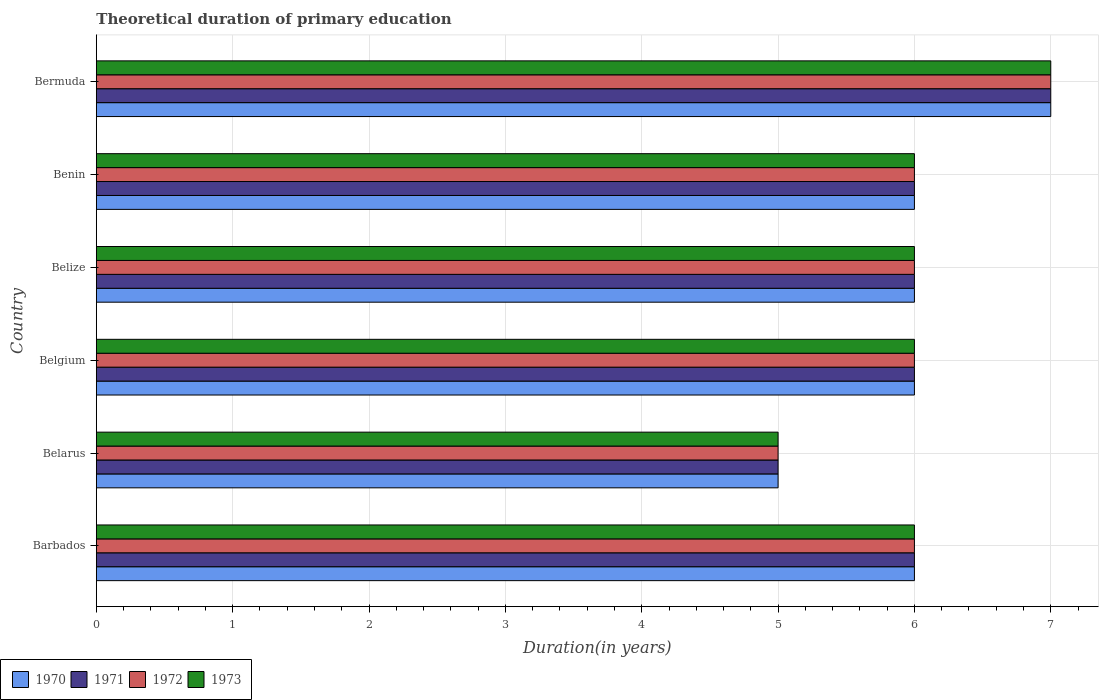How many different coloured bars are there?
Your answer should be compact. 4. How many groups of bars are there?
Your answer should be compact. 6. Are the number of bars on each tick of the Y-axis equal?
Your response must be concise. Yes. What is the label of the 1st group of bars from the top?
Provide a succinct answer. Bermuda. In how many cases, is the number of bars for a given country not equal to the number of legend labels?
Your response must be concise. 0. Across all countries, what is the minimum total theoretical duration of primary education in 1972?
Give a very brief answer. 5. In which country was the total theoretical duration of primary education in 1972 maximum?
Ensure brevity in your answer.  Bermuda. In which country was the total theoretical duration of primary education in 1973 minimum?
Your answer should be very brief. Belarus. What is the total total theoretical duration of primary education in 1970 in the graph?
Make the answer very short. 36. What is the difference between the total theoretical duration of primary education in 1970 in Belize and that in Bermuda?
Offer a terse response. -1. What is the average total theoretical duration of primary education in 1971 per country?
Give a very brief answer. 6. In how many countries, is the total theoretical duration of primary education in 1971 greater than 0.8 years?
Provide a succinct answer. 6. What is the ratio of the total theoretical duration of primary education in 1972 in Belgium to that in Bermuda?
Keep it short and to the point. 0.86. What is the difference between the highest and the second highest total theoretical duration of primary education in 1973?
Ensure brevity in your answer.  1. What is the difference between the highest and the lowest total theoretical duration of primary education in 1972?
Provide a succinct answer. 2. In how many countries, is the total theoretical duration of primary education in 1971 greater than the average total theoretical duration of primary education in 1971 taken over all countries?
Your response must be concise. 1. What does the 1st bar from the bottom in Belarus represents?
Your response must be concise. 1970. How many countries are there in the graph?
Your answer should be very brief. 6. How many legend labels are there?
Your response must be concise. 4. What is the title of the graph?
Make the answer very short. Theoretical duration of primary education. What is the label or title of the X-axis?
Ensure brevity in your answer.  Duration(in years). What is the label or title of the Y-axis?
Make the answer very short. Country. What is the Duration(in years) of 1971 in Barbados?
Ensure brevity in your answer.  6. What is the Duration(in years) of 1973 in Barbados?
Provide a succinct answer. 6. What is the Duration(in years) of 1970 in Belarus?
Your answer should be compact. 5. What is the Duration(in years) in 1972 in Belarus?
Your answer should be very brief. 5. What is the Duration(in years) of 1973 in Belarus?
Give a very brief answer. 5. What is the Duration(in years) in 1971 in Belgium?
Ensure brevity in your answer.  6. What is the Duration(in years) of 1973 in Belgium?
Your response must be concise. 6. What is the Duration(in years) in 1970 in Belize?
Your answer should be very brief. 6. What is the Duration(in years) in 1971 in Belize?
Provide a short and direct response. 6. What is the Duration(in years) of 1973 in Belize?
Keep it short and to the point. 6. What is the Duration(in years) of 1971 in Benin?
Make the answer very short. 6. What is the Duration(in years) of 1972 in Benin?
Provide a short and direct response. 6. What is the Duration(in years) of 1970 in Bermuda?
Offer a terse response. 7. Across all countries, what is the maximum Duration(in years) of 1972?
Offer a very short reply. 7. Across all countries, what is the maximum Duration(in years) in 1973?
Keep it short and to the point. 7. Across all countries, what is the minimum Duration(in years) of 1971?
Your answer should be very brief. 5. Across all countries, what is the minimum Duration(in years) of 1973?
Provide a short and direct response. 5. What is the total Duration(in years) in 1970 in the graph?
Your response must be concise. 36. What is the total Duration(in years) in 1971 in the graph?
Provide a succinct answer. 36. What is the total Duration(in years) of 1972 in the graph?
Provide a short and direct response. 36. What is the total Duration(in years) in 1973 in the graph?
Your answer should be compact. 36. What is the difference between the Duration(in years) in 1970 in Barbados and that in Belarus?
Make the answer very short. 1. What is the difference between the Duration(in years) of 1972 in Barbados and that in Belarus?
Offer a very short reply. 1. What is the difference between the Duration(in years) of 1970 in Barbados and that in Belgium?
Provide a short and direct response. 0. What is the difference between the Duration(in years) in 1972 in Barbados and that in Belgium?
Provide a succinct answer. 0. What is the difference between the Duration(in years) of 1970 in Barbados and that in Belize?
Your answer should be compact. 0. What is the difference between the Duration(in years) of 1971 in Barbados and that in Belize?
Your answer should be very brief. 0. What is the difference between the Duration(in years) of 1970 in Barbados and that in Benin?
Offer a terse response. 0. What is the difference between the Duration(in years) of 1972 in Barbados and that in Benin?
Your answer should be compact. 0. What is the difference between the Duration(in years) of 1970 in Barbados and that in Bermuda?
Provide a succinct answer. -1. What is the difference between the Duration(in years) in 1971 in Barbados and that in Bermuda?
Make the answer very short. -1. What is the difference between the Duration(in years) in 1972 in Barbados and that in Bermuda?
Keep it short and to the point. -1. What is the difference between the Duration(in years) of 1970 in Belarus and that in Belgium?
Keep it short and to the point. -1. What is the difference between the Duration(in years) of 1971 in Belarus and that in Belgium?
Your answer should be very brief. -1. What is the difference between the Duration(in years) in 1972 in Belarus and that in Belgium?
Give a very brief answer. -1. What is the difference between the Duration(in years) in 1973 in Belarus and that in Belgium?
Offer a terse response. -1. What is the difference between the Duration(in years) in 1970 in Belarus and that in Belize?
Your answer should be compact. -1. What is the difference between the Duration(in years) in 1971 in Belarus and that in Belize?
Give a very brief answer. -1. What is the difference between the Duration(in years) in 1973 in Belarus and that in Belize?
Your response must be concise. -1. What is the difference between the Duration(in years) in 1970 in Belarus and that in Benin?
Ensure brevity in your answer.  -1. What is the difference between the Duration(in years) of 1971 in Belarus and that in Benin?
Offer a terse response. -1. What is the difference between the Duration(in years) of 1973 in Belarus and that in Benin?
Offer a terse response. -1. What is the difference between the Duration(in years) in 1972 in Belarus and that in Bermuda?
Your answer should be very brief. -2. What is the difference between the Duration(in years) in 1970 in Belgium and that in Belize?
Keep it short and to the point. 0. What is the difference between the Duration(in years) of 1970 in Belgium and that in Benin?
Make the answer very short. 0. What is the difference between the Duration(in years) in 1971 in Belgium and that in Bermuda?
Offer a terse response. -1. What is the difference between the Duration(in years) of 1973 in Belgium and that in Bermuda?
Ensure brevity in your answer.  -1. What is the difference between the Duration(in years) in 1970 in Belize and that in Benin?
Your answer should be compact. 0. What is the difference between the Duration(in years) in 1972 in Belize and that in Benin?
Give a very brief answer. 0. What is the difference between the Duration(in years) in 1970 in Belize and that in Bermuda?
Your response must be concise. -1. What is the difference between the Duration(in years) in 1971 in Belize and that in Bermuda?
Make the answer very short. -1. What is the difference between the Duration(in years) in 1972 in Belize and that in Bermuda?
Offer a terse response. -1. What is the difference between the Duration(in years) in 1972 in Benin and that in Bermuda?
Offer a very short reply. -1. What is the difference between the Duration(in years) in 1970 in Barbados and the Duration(in years) in 1971 in Belarus?
Your response must be concise. 1. What is the difference between the Duration(in years) of 1970 in Barbados and the Duration(in years) of 1973 in Belarus?
Offer a very short reply. 1. What is the difference between the Duration(in years) of 1971 in Barbados and the Duration(in years) of 1972 in Belarus?
Your response must be concise. 1. What is the difference between the Duration(in years) in 1970 in Barbados and the Duration(in years) in 1972 in Belgium?
Give a very brief answer. 0. What is the difference between the Duration(in years) of 1970 in Barbados and the Duration(in years) of 1973 in Belgium?
Provide a short and direct response. 0. What is the difference between the Duration(in years) of 1971 in Barbados and the Duration(in years) of 1972 in Belgium?
Your answer should be very brief. 0. What is the difference between the Duration(in years) of 1972 in Barbados and the Duration(in years) of 1973 in Belgium?
Your answer should be very brief. 0. What is the difference between the Duration(in years) of 1970 in Barbados and the Duration(in years) of 1972 in Belize?
Give a very brief answer. 0. What is the difference between the Duration(in years) in 1970 in Barbados and the Duration(in years) in 1973 in Belize?
Make the answer very short. 0. What is the difference between the Duration(in years) of 1971 in Barbados and the Duration(in years) of 1972 in Benin?
Ensure brevity in your answer.  0. What is the difference between the Duration(in years) of 1971 in Barbados and the Duration(in years) of 1973 in Benin?
Ensure brevity in your answer.  0. What is the difference between the Duration(in years) of 1972 in Barbados and the Duration(in years) of 1973 in Benin?
Ensure brevity in your answer.  0. What is the difference between the Duration(in years) in 1970 in Barbados and the Duration(in years) in 1972 in Bermuda?
Keep it short and to the point. -1. What is the difference between the Duration(in years) in 1971 in Barbados and the Duration(in years) in 1973 in Bermuda?
Your answer should be compact. -1. What is the difference between the Duration(in years) in 1970 in Belarus and the Duration(in years) in 1971 in Belgium?
Offer a terse response. -1. What is the difference between the Duration(in years) of 1970 in Belarus and the Duration(in years) of 1972 in Belgium?
Give a very brief answer. -1. What is the difference between the Duration(in years) of 1970 in Belarus and the Duration(in years) of 1973 in Belgium?
Give a very brief answer. -1. What is the difference between the Duration(in years) in 1971 in Belarus and the Duration(in years) in 1973 in Belgium?
Keep it short and to the point. -1. What is the difference between the Duration(in years) in 1971 in Belarus and the Duration(in years) in 1973 in Belize?
Provide a short and direct response. -1. What is the difference between the Duration(in years) of 1970 in Belarus and the Duration(in years) of 1971 in Benin?
Your answer should be very brief. -1. What is the difference between the Duration(in years) of 1970 in Belarus and the Duration(in years) of 1972 in Benin?
Your answer should be compact. -1. What is the difference between the Duration(in years) of 1971 in Belarus and the Duration(in years) of 1973 in Benin?
Make the answer very short. -1. What is the difference between the Duration(in years) in 1972 in Belarus and the Duration(in years) in 1973 in Benin?
Your answer should be compact. -1. What is the difference between the Duration(in years) of 1970 in Belarus and the Duration(in years) of 1971 in Bermuda?
Your response must be concise. -2. What is the difference between the Duration(in years) of 1971 in Belarus and the Duration(in years) of 1972 in Bermuda?
Make the answer very short. -2. What is the difference between the Duration(in years) of 1971 in Belarus and the Duration(in years) of 1973 in Bermuda?
Your answer should be compact. -2. What is the difference between the Duration(in years) of 1972 in Belarus and the Duration(in years) of 1973 in Bermuda?
Make the answer very short. -2. What is the difference between the Duration(in years) of 1970 in Belgium and the Duration(in years) of 1972 in Belize?
Make the answer very short. 0. What is the difference between the Duration(in years) of 1970 in Belgium and the Duration(in years) of 1973 in Benin?
Offer a very short reply. 0. What is the difference between the Duration(in years) of 1971 in Belgium and the Duration(in years) of 1972 in Benin?
Provide a short and direct response. 0. What is the difference between the Duration(in years) of 1970 in Belgium and the Duration(in years) of 1971 in Bermuda?
Your response must be concise. -1. What is the difference between the Duration(in years) in 1970 in Belgium and the Duration(in years) in 1973 in Bermuda?
Give a very brief answer. -1. What is the difference between the Duration(in years) of 1971 in Belgium and the Duration(in years) of 1973 in Bermuda?
Provide a short and direct response. -1. What is the difference between the Duration(in years) of 1972 in Belgium and the Duration(in years) of 1973 in Bermuda?
Offer a terse response. -1. What is the difference between the Duration(in years) in 1970 in Belize and the Duration(in years) in 1971 in Benin?
Offer a very short reply. 0. What is the difference between the Duration(in years) of 1970 in Belize and the Duration(in years) of 1973 in Benin?
Keep it short and to the point. 0. What is the difference between the Duration(in years) of 1971 in Belize and the Duration(in years) of 1972 in Benin?
Ensure brevity in your answer.  0. What is the difference between the Duration(in years) of 1970 in Belize and the Duration(in years) of 1972 in Bermuda?
Your response must be concise. -1. What is the difference between the Duration(in years) in 1970 in Belize and the Duration(in years) in 1973 in Bermuda?
Offer a very short reply. -1. What is the difference between the Duration(in years) of 1971 in Belize and the Duration(in years) of 1973 in Bermuda?
Your response must be concise. -1. What is the difference between the Duration(in years) in 1972 in Belize and the Duration(in years) in 1973 in Bermuda?
Provide a succinct answer. -1. What is the difference between the Duration(in years) in 1971 in Benin and the Duration(in years) in 1972 in Bermuda?
Give a very brief answer. -1. What is the difference between the Duration(in years) in 1971 in Benin and the Duration(in years) in 1973 in Bermuda?
Offer a terse response. -1. What is the difference between the Duration(in years) in 1972 in Benin and the Duration(in years) in 1973 in Bermuda?
Ensure brevity in your answer.  -1. What is the difference between the Duration(in years) of 1970 and Duration(in years) of 1971 in Barbados?
Offer a terse response. 0. What is the difference between the Duration(in years) of 1971 and Duration(in years) of 1972 in Barbados?
Provide a succinct answer. 0. What is the difference between the Duration(in years) in 1972 and Duration(in years) in 1973 in Barbados?
Your response must be concise. 0. What is the difference between the Duration(in years) of 1970 and Duration(in years) of 1971 in Belarus?
Offer a terse response. 0. What is the difference between the Duration(in years) in 1970 and Duration(in years) in 1972 in Belarus?
Provide a short and direct response. 0. What is the difference between the Duration(in years) in 1970 and Duration(in years) in 1973 in Belarus?
Provide a succinct answer. 0. What is the difference between the Duration(in years) of 1971 and Duration(in years) of 1972 in Belarus?
Give a very brief answer. 0. What is the difference between the Duration(in years) in 1971 and Duration(in years) in 1973 in Belarus?
Give a very brief answer. 0. What is the difference between the Duration(in years) in 1972 and Duration(in years) in 1973 in Belarus?
Give a very brief answer. 0. What is the difference between the Duration(in years) in 1971 and Duration(in years) in 1972 in Belgium?
Ensure brevity in your answer.  0. What is the difference between the Duration(in years) in 1971 and Duration(in years) in 1973 in Belgium?
Provide a short and direct response. 0. What is the difference between the Duration(in years) in 1972 and Duration(in years) in 1973 in Belgium?
Make the answer very short. 0. What is the difference between the Duration(in years) of 1970 and Duration(in years) of 1972 in Belize?
Ensure brevity in your answer.  0. What is the difference between the Duration(in years) of 1970 and Duration(in years) of 1973 in Belize?
Give a very brief answer. 0. What is the difference between the Duration(in years) in 1971 and Duration(in years) in 1972 in Belize?
Your answer should be very brief. 0. What is the difference between the Duration(in years) in 1971 and Duration(in years) in 1973 in Belize?
Give a very brief answer. 0. What is the difference between the Duration(in years) of 1970 and Duration(in years) of 1972 in Benin?
Keep it short and to the point. 0. What is the difference between the Duration(in years) in 1970 and Duration(in years) in 1973 in Benin?
Offer a terse response. 0. What is the difference between the Duration(in years) in 1970 and Duration(in years) in 1972 in Bermuda?
Give a very brief answer. 0. What is the difference between the Duration(in years) of 1972 and Duration(in years) of 1973 in Bermuda?
Your answer should be very brief. 0. What is the ratio of the Duration(in years) of 1973 in Barbados to that in Belarus?
Keep it short and to the point. 1.2. What is the ratio of the Duration(in years) of 1973 in Barbados to that in Belgium?
Your response must be concise. 1. What is the ratio of the Duration(in years) of 1971 in Barbados to that in Belize?
Keep it short and to the point. 1. What is the ratio of the Duration(in years) in 1973 in Barbados to that in Belize?
Give a very brief answer. 1. What is the ratio of the Duration(in years) in 1970 in Barbados to that in Benin?
Provide a short and direct response. 1. What is the ratio of the Duration(in years) of 1971 in Barbados to that in Benin?
Provide a short and direct response. 1. What is the ratio of the Duration(in years) of 1973 in Barbados to that in Benin?
Your answer should be compact. 1. What is the ratio of the Duration(in years) in 1970 in Barbados to that in Bermuda?
Make the answer very short. 0.86. What is the ratio of the Duration(in years) of 1972 in Barbados to that in Bermuda?
Your response must be concise. 0.86. What is the ratio of the Duration(in years) of 1973 in Barbados to that in Bermuda?
Make the answer very short. 0.86. What is the ratio of the Duration(in years) in 1970 in Belarus to that in Belgium?
Ensure brevity in your answer.  0.83. What is the ratio of the Duration(in years) of 1971 in Belarus to that in Belgium?
Keep it short and to the point. 0.83. What is the ratio of the Duration(in years) in 1970 in Belarus to that in Belize?
Make the answer very short. 0.83. What is the ratio of the Duration(in years) of 1972 in Belarus to that in Belize?
Provide a short and direct response. 0.83. What is the ratio of the Duration(in years) of 1973 in Belarus to that in Belize?
Keep it short and to the point. 0.83. What is the ratio of the Duration(in years) of 1970 in Belarus to that in Benin?
Ensure brevity in your answer.  0.83. What is the ratio of the Duration(in years) of 1971 in Belarus to that in Bermuda?
Provide a short and direct response. 0.71. What is the ratio of the Duration(in years) in 1971 in Belgium to that in Belize?
Give a very brief answer. 1. What is the ratio of the Duration(in years) in 1972 in Belgium to that in Belize?
Your answer should be very brief. 1. What is the ratio of the Duration(in years) in 1973 in Belgium to that in Belize?
Offer a terse response. 1. What is the ratio of the Duration(in years) of 1970 in Belgium to that in Benin?
Your answer should be compact. 1. What is the ratio of the Duration(in years) of 1970 in Belgium to that in Bermuda?
Offer a very short reply. 0.86. What is the ratio of the Duration(in years) of 1971 in Belgium to that in Bermuda?
Offer a very short reply. 0.86. What is the ratio of the Duration(in years) in 1972 in Belgium to that in Bermuda?
Offer a terse response. 0.86. What is the ratio of the Duration(in years) in 1973 in Belgium to that in Bermuda?
Your answer should be compact. 0.86. What is the ratio of the Duration(in years) in 1970 in Belize to that in Benin?
Offer a terse response. 1. What is the ratio of the Duration(in years) of 1971 in Belize to that in Benin?
Give a very brief answer. 1. What is the ratio of the Duration(in years) in 1973 in Belize to that in Benin?
Keep it short and to the point. 1. What is the ratio of the Duration(in years) in 1970 in Belize to that in Bermuda?
Provide a short and direct response. 0.86. What is the ratio of the Duration(in years) of 1973 in Belize to that in Bermuda?
Keep it short and to the point. 0.86. What is the ratio of the Duration(in years) of 1972 in Benin to that in Bermuda?
Your answer should be very brief. 0.86. What is the difference between the highest and the second highest Duration(in years) in 1970?
Keep it short and to the point. 1. What is the difference between the highest and the second highest Duration(in years) in 1972?
Your response must be concise. 1. What is the difference between the highest and the lowest Duration(in years) in 1972?
Provide a short and direct response. 2. 